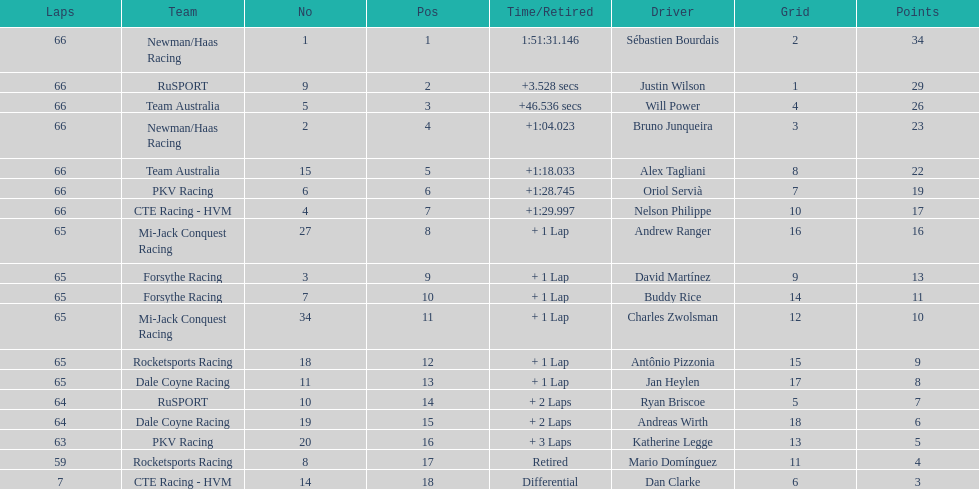Which country is represented by the most drivers? United Kingdom. 